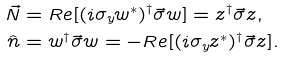Convert formula to latex. <formula><loc_0><loc_0><loc_500><loc_500>\vec { N } & = R e [ ( i \sigma _ { y } w ^ { * } ) ^ { \dagger } \vec { \sigma } w ] = z ^ { \dagger } \vec { \sigma } z , \\ \hat { n } & = w ^ { \dagger } \vec { \sigma } w = - R e [ ( i \sigma _ { y } z ^ { * } ) ^ { \dagger } \vec { \sigma } z ] .</formula> 